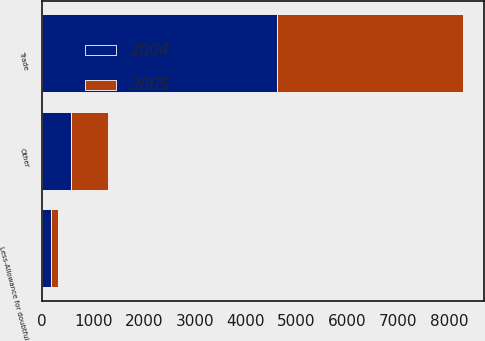<chart> <loc_0><loc_0><loc_500><loc_500><stacked_bar_chart><ecel><fcel>Trade<fcel>Other<fcel>Less-Allowance for doubtful<nl><fcel>2004<fcel>4623<fcel>573<fcel>179<nl><fcel>2005<fcel>3656<fcel>724<fcel>137<nl></chart> 